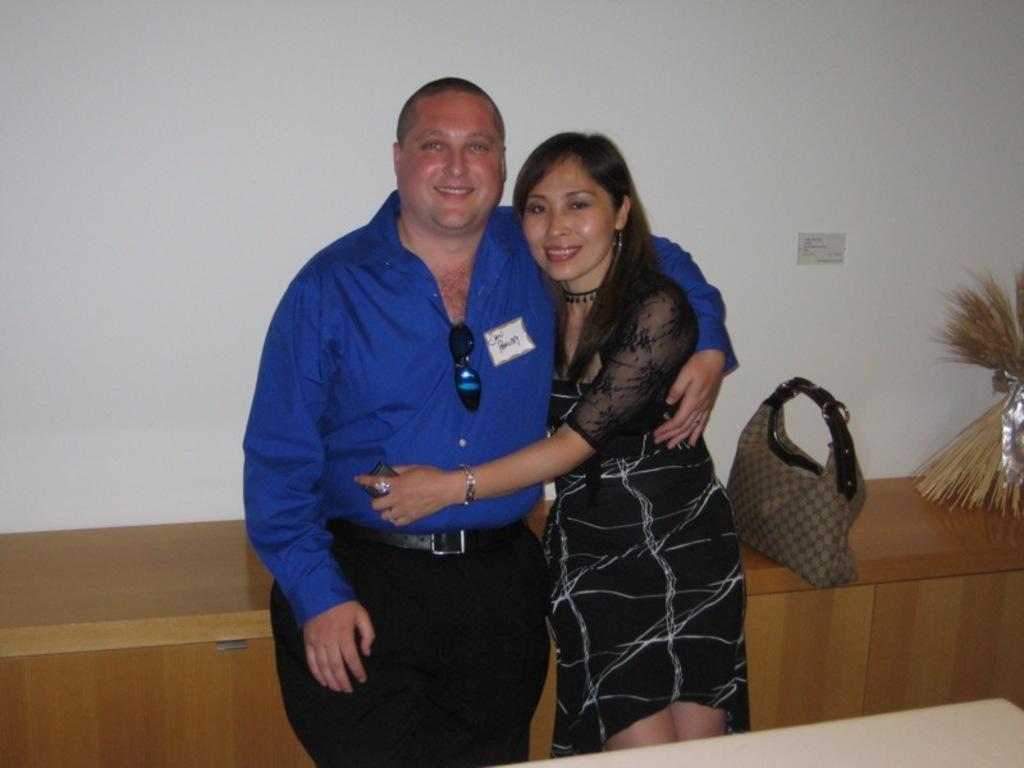Please provide a concise description of this image. In this image there is a man and women. A man who is wearing a blue shirt and a black pant is hugging to the women. On the background we can see a table. Besides her there is a bag. On the wall there is a socket. 